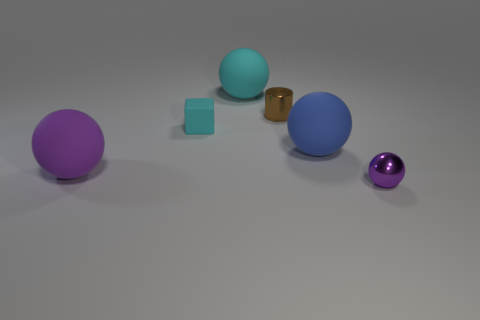Add 2 matte balls. How many objects exist? 8 Subtract all cyan spheres. How many spheres are left? 3 Subtract all green cylinders. How many purple balls are left? 2 Subtract 1 balls. How many balls are left? 3 Subtract all blue balls. How many balls are left? 3 Subtract all cylinders. How many objects are left? 5 Subtract 2 purple spheres. How many objects are left? 4 Subtract all yellow blocks. Subtract all gray cylinders. How many blocks are left? 1 Subtract all spheres. Subtract all cylinders. How many objects are left? 1 Add 1 purple matte things. How many purple matte things are left? 2 